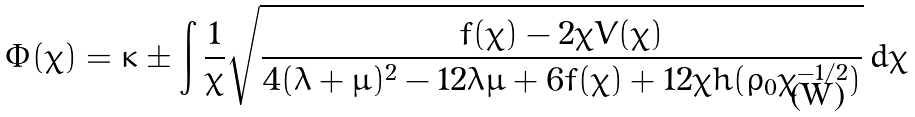<formula> <loc_0><loc_0><loc_500><loc_500>\Phi ( \chi ) = \kappa \pm \int \frac { 1 } { \chi } \sqrt { \frac { f ( \chi ) - 2 \chi V ( \chi ) } { 4 ( \lambda + \mu ) ^ { 2 } - 1 2 \lambda \mu + 6 f ( \chi ) + 1 2 \chi h ( \rho _ { 0 } \chi ^ { - 1 / 2 } ) } } \, d \chi</formula> 